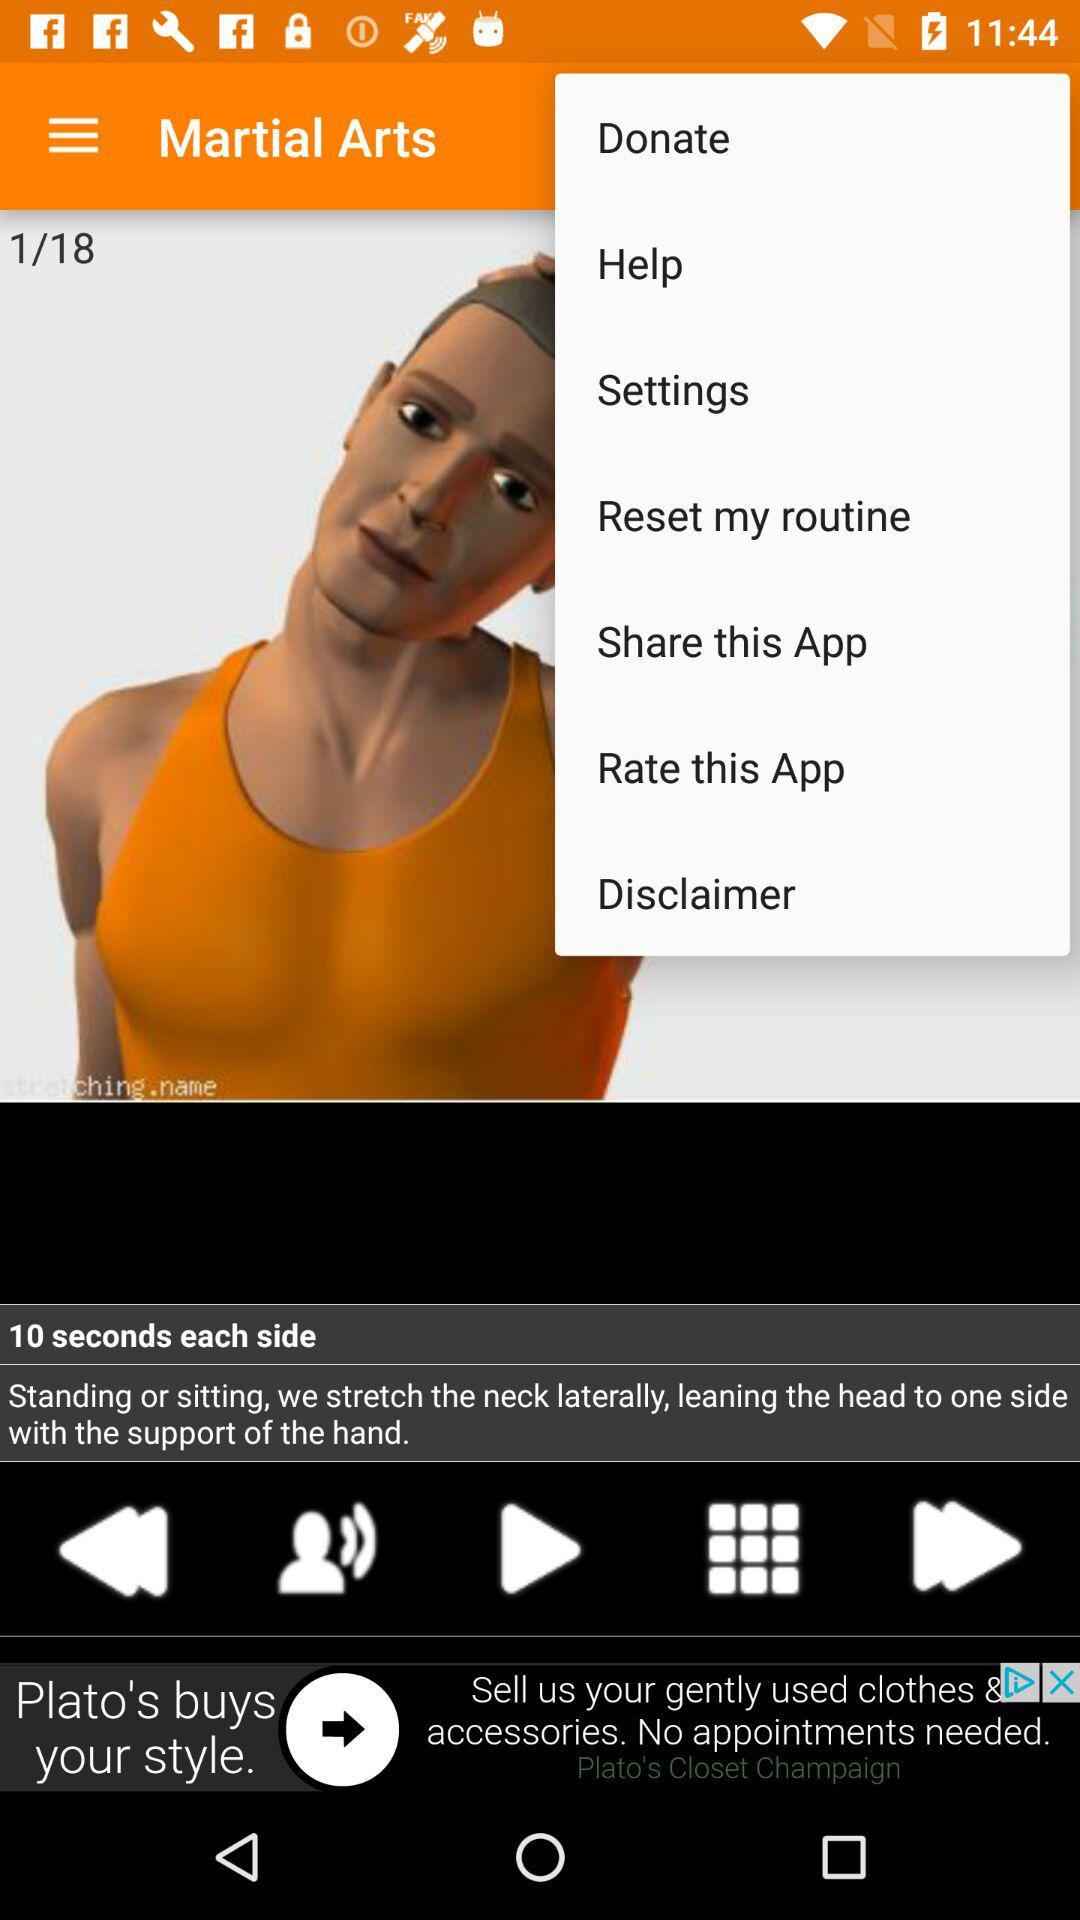What is the duration of each side? The duration of each side is 10 seconds. 